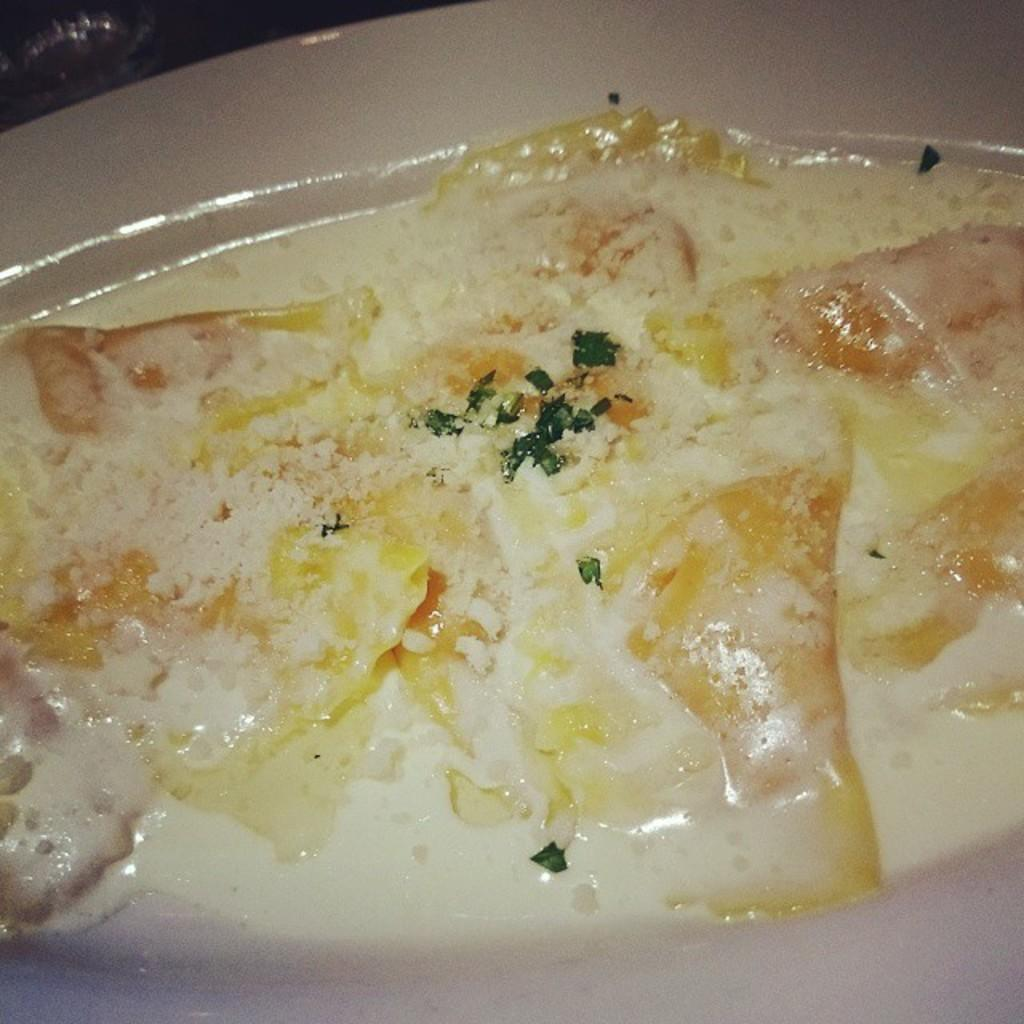What object is present in the image that typically holds food? There is a plate in the image. What is on the plate? The plate contains food. What type of quince is being served by the father in the image? There is no father or quince present in the image; it only features a plate with food. 